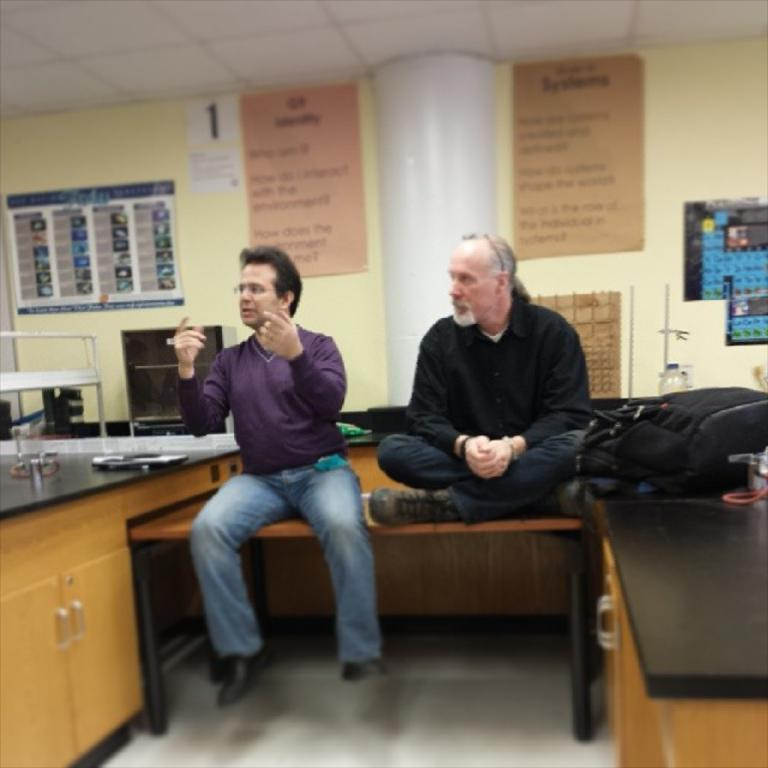What type of structure can be seen in the image? There is a wall in the image. What is hanging on the wall? There is a banner in the image. What are the two people in the image doing? They are sitting on a bench in the image. What electronic device is visible in the image? There is a laptop visible in the image. Can you tell me how many kitties are sitting on the laptop in the image? There are no kitties present in the image, and the laptop is not being used as a seat. 